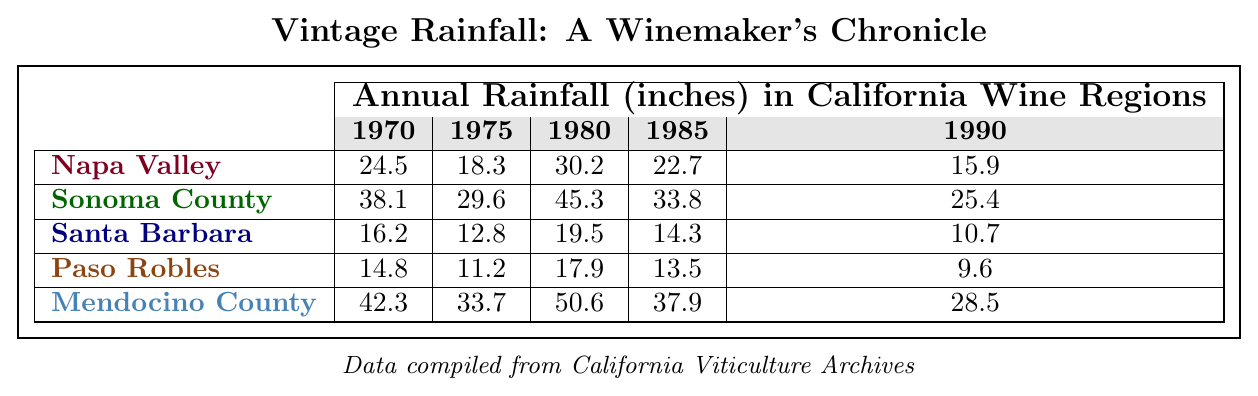What was the rainfall in Napa Valley in 1980? In the table, under the Napa Valley row and the 1980 column, the value is 30.2 inches.
Answer: 30.2 inches Which region had the highest average rainfall from 1970 to 1990? To find the average rainfall for each region, sum the rainfall values for each year and divide by the number of years. Napa Valley: (24.5 + 18.3 + 30.2 + 22.7 + 15.9) / 5 = 22.32; Sonoma County: (38.1 + 29.6 + 45.3 + 33.8 + 25.4) / 5 = 34.44; Santa Barbara: (16.2 + 12.8 + 19.5 + 14.3 + 10.7) / 5 = 14.70; Paso Robles: (14.8 + 11.2 + 17.9 + 13.5 + 9.6) / 5 = 13.24; Mendocino County: (42.3 + 33.7 + 50.6 + 37.9 + 28.5) / 5 = 38.24. The highest average rainfall is for Sonoma County at 34.44 inches.
Answer: Sonoma County Was there a decrease in rainfall in Santa Barbara from 1970 to 1990? The values in the table for Santa Barbara are 16.2 inches in 1970 and 10.7 inches in 1990. Since 10.7 is less than 16.2, there was a decrease.
Answer: Yes What region experienced the most significant decrease in rainfall between 1970 and 1990? First, identify the rainfall in each region for both years. Napa Valley decreased from 24.5 to 15.9 (8.6); Sonoma County from 38.1 to 25.4 (12.7); Santa Barbara from 16.2 to 10.7 (5.5); Paso Robles from 14.8 to 9.6 (5.2); and Mendocino County from 42.3 to 28.5 (13.8). The largest drop is 12.7 inches in Sonoma County.
Answer: Sonoma County What was the total rainfall for Mendocino County over the years? Add the rainfall values for Mendocino County across all years: 42.3 + 33.7 + 50.6 + 37.9 + 28.5 = 193.0 inches.
Answer: 193.0 inches Did Napa Valley have more rainfall than Paso Robles in any year between 1970 and 1990? Compare each year for both regions. In 1970, Napa had 24.5 and Paso had 14.8 (yes); 1975: 18.3 vs 11.2 (yes); 1980: 30.2 vs 17.9 (yes); 1985: 22.7 vs 13.5 (yes); 1990: 15.9 vs 9.6 (yes). Napa Valley consistently had more rainfall.
Answer: Yes In which year was the rainfall in Santa Barbara the lowest? Looking at the Santa Barbara values across years: 16.2 (1970), 12.8 (1975), 19.5 (1980), 14.3 (1985), and 10.7 (1990), the lowest value is 10.7 in 1990.
Answer: 1990 What is the difference in rainfall between the highest and lowest rainfall recorded in 1985? The maximum rainfall in 1985 was Mendocino County, with 37.9 inches, and the minimum was Paso Robles, with 13.5 inches. The difference is 37.9 - 13.5 = 24.4 inches.
Answer: 24.4 inches Which region had the least rainfall overall? From the total rainfall calculations for each region, Santa Barbara has the lowest total of 73.5 inches when compared to others.
Answer: Santa Barbara 